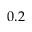Convert formula to latex. <formula><loc_0><loc_0><loc_500><loc_500>0 . 2</formula> 